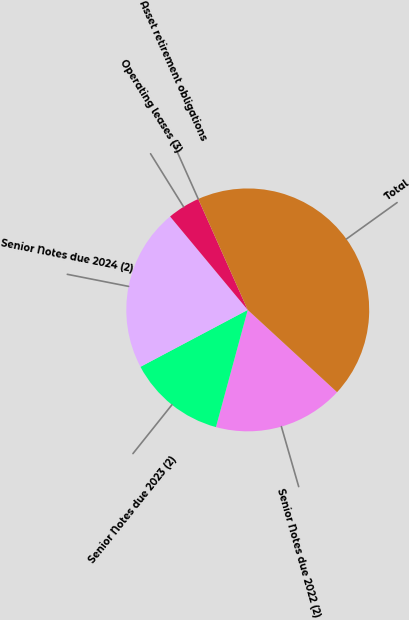<chart> <loc_0><loc_0><loc_500><loc_500><pie_chart><fcel>Senior Notes due 2022 (2)<fcel>Senior Notes due 2023 (2)<fcel>Senior Notes due 2024 (2)<fcel>Operating leases (3)<fcel>Asset retirement obligations<fcel>Total<nl><fcel>17.37%<fcel>13.02%<fcel>21.72%<fcel>4.36%<fcel>0.0%<fcel>43.53%<nl></chart> 